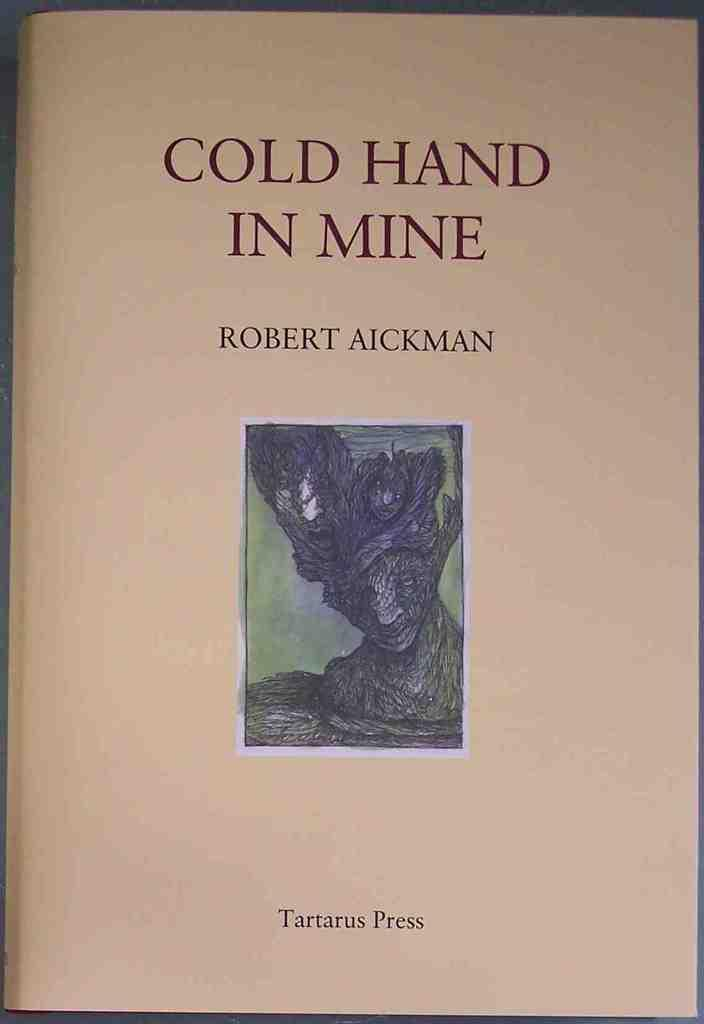<image>
Write a terse but informative summary of the picture. Robert Aickman wrote a book called Cold Hand in Mind that was published by Tartarus press 